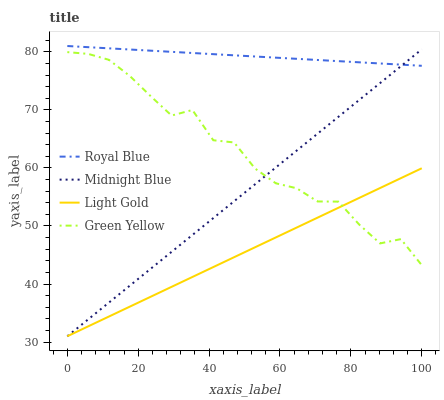Does Light Gold have the minimum area under the curve?
Answer yes or no. Yes. Does Royal Blue have the maximum area under the curve?
Answer yes or no. Yes. Does Green Yellow have the minimum area under the curve?
Answer yes or no. No. Does Green Yellow have the maximum area under the curve?
Answer yes or no. No. Is Light Gold the smoothest?
Answer yes or no. Yes. Is Green Yellow the roughest?
Answer yes or no. Yes. Is Green Yellow the smoothest?
Answer yes or no. No. Is Light Gold the roughest?
Answer yes or no. No. Does Light Gold have the lowest value?
Answer yes or no. Yes. Does Green Yellow have the lowest value?
Answer yes or no. No. Does Royal Blue have the highest value?
Answer yes or no. Yes. Does Green Yellow have the highest value?
Answer yes or no. No. Is Green Yellow less than Royal Blue?
Answer yes or no. Yes. Is Royal Blue greater than Light Gold?
Answer yes or no. Yes. Does Light Gold intersect Midnight Blue?
Answer yes or no. Yes. Is Light Gold less than Midnight Blue?
Answer yes or no. No. Is Light Gold greater than Midnight Blue?
Answer yes or no. No. Does Green Yellow intersect Royal Blue?
Answer yes or no. No. 